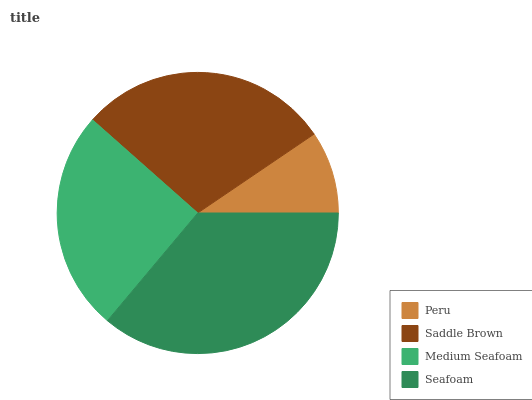Is Peru the minimum?
Answer yes or no. Yes. Is Seafoam the maximum?
Answer yes or no. Yes. Is Saddle Brown the minimum?
Answer yes or no. No. Is Saddle Brown the maximum?
Answer yes or no. No. Is Saddle Brown greater than Peru?
Answer yes or no. Yes. Is Peru less than Saddle Brown?
Answer yes or no. Yes. Is Peru greater than Saddle Brown?
Answer yes or no. No. Is Saddle Brown less than Peru?
Answer yes or no. No. Is Saddle Brown the high median?
Answer yes or no. Yes. Is Medium Seafoam the low median?
Answer yes or no. Yes. Is Medium Seafoam the high median?
Answer yes or no. No. Is Saddle Brown the low median?
Answer yes or no. No. 